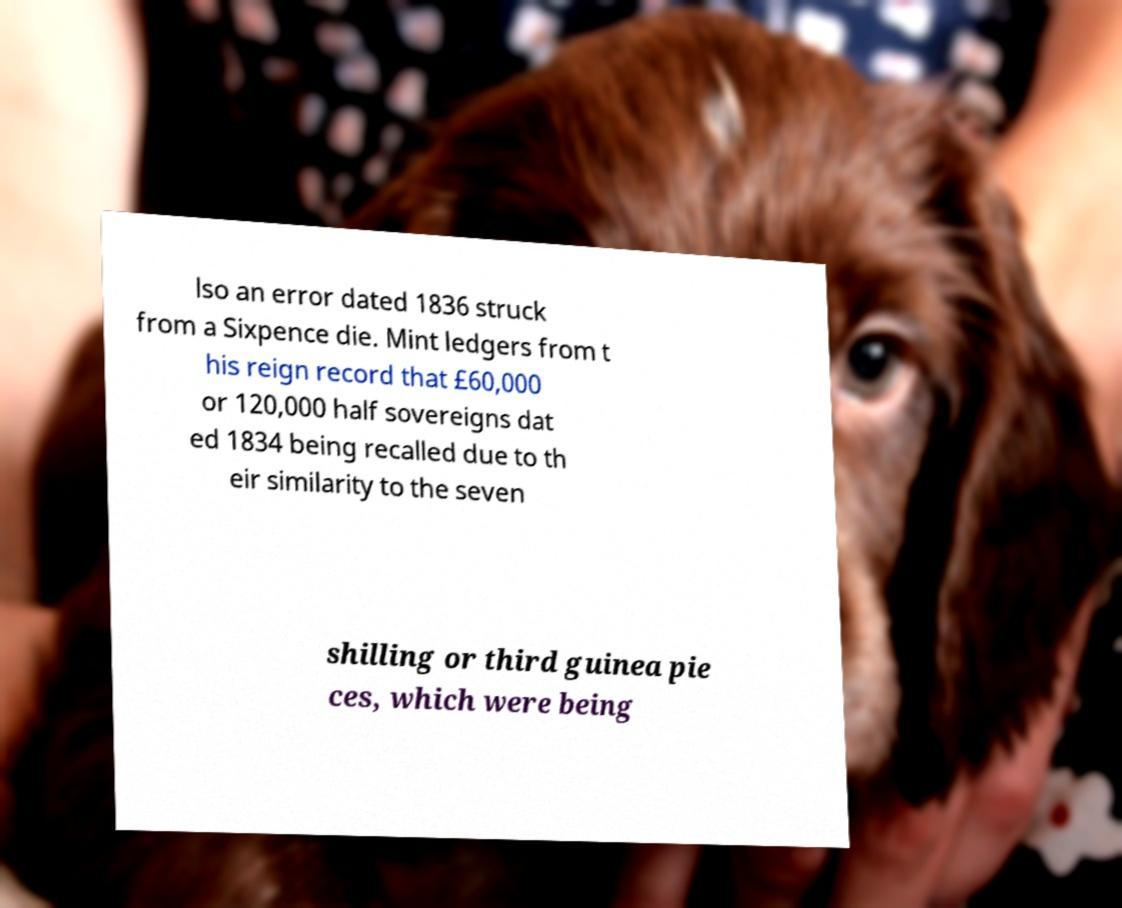Can you accurately transcribe the text from the provided image for me? lso an error dated 1836 struck from a Sixpence die. Mint ledgers from t his reign record that £60,000 or 120,000 half sovereigns dat ed 1834 being recalled due to th eir similarity to the seven shilling or third guinea pie ces, which were being 